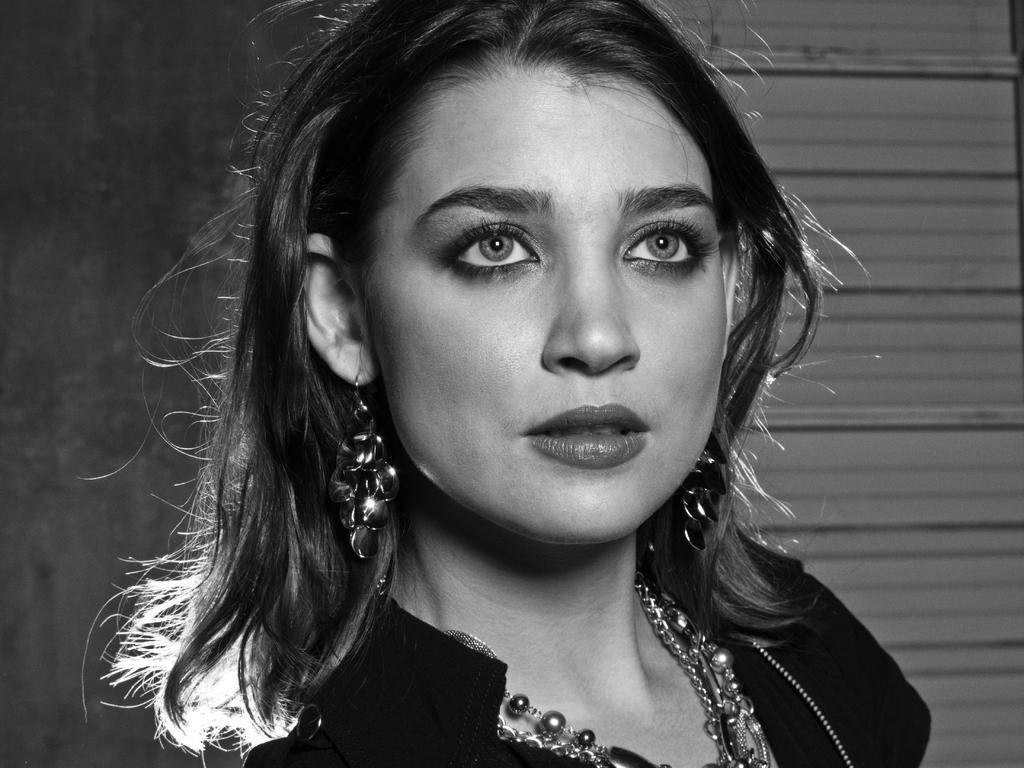Could you give a brief overview of what you see in this image? This is a black and white image. We can see a person and the background. 